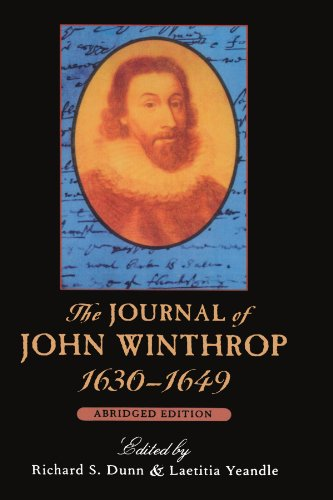Can you describe some of the major events that John Winthrop wrote about in his journal? John Winthrop's journal includes detailed accounts of the founding of Boston, the Puritan religious context, and interactions with Native American tribes. It also discusses the various challenges the settlers faced, including harsh winters, disease, and resource scarcity. 